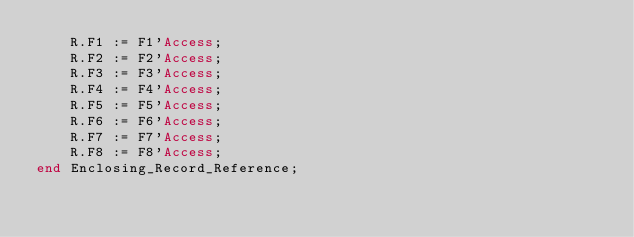Convert code to text. <code><loc_0><loc_0><loc_500><loc_500><_Ada_>    R.F1 := F1'Access;
    R.F2 := F2'Access;
    R.F3 := F3'Access;
    R.F4 := F4'Access;
    R.F5 := F5'Access;
    R.F6 := F6'Access;
    R.F7 := F7'Access;
    R.F8 := F8'Access;
end Enclosing_Record_Reference;
</code> 